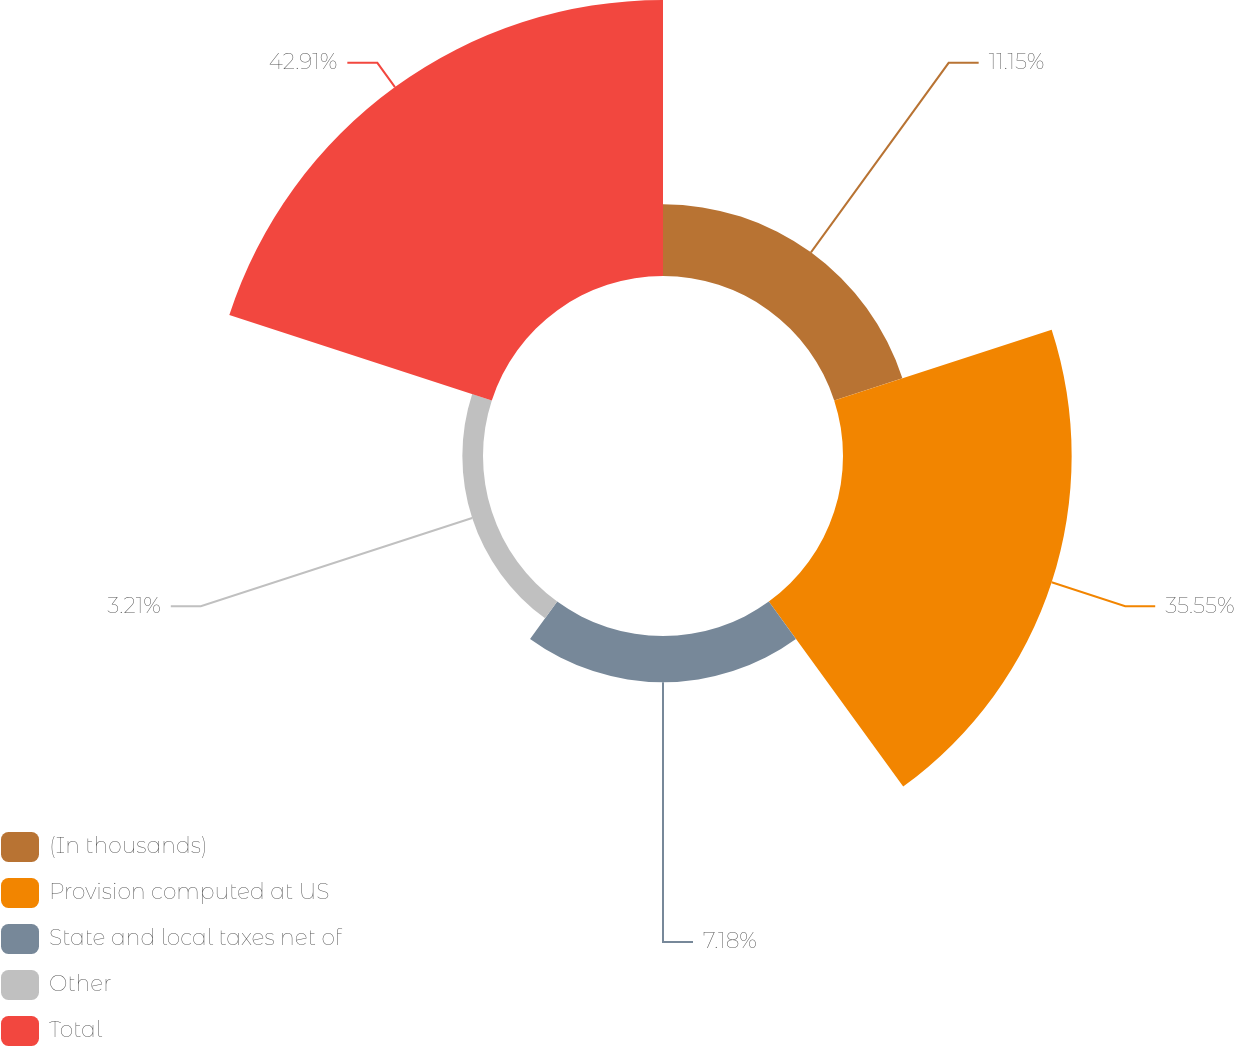<chart> <loc_0><loc_0><loc_500><loc_500><pie_chart><fcel>(In thousands)<fcel>Provision computed at US<fcel>State and local taxes net of<fcel>Other<fcel>Total<nl><fcel>11.15%<fcel>35.55%<fcel>7.18%<fcel>3.21%<fcel>42.91%<nl></chart> 